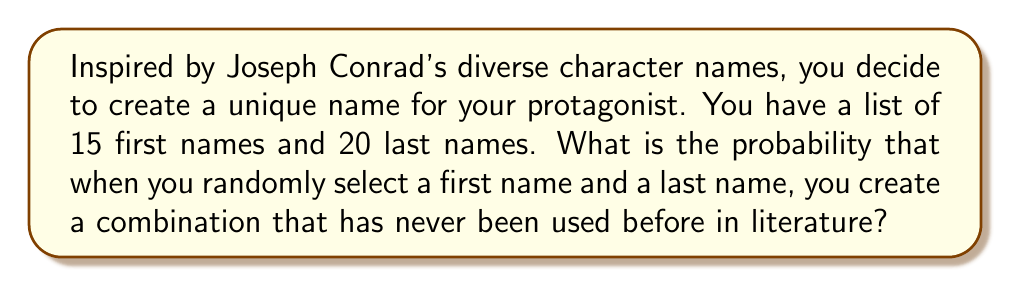Solve this math problem. Let's approach this step-by-step:

1) First, we need to calculate the total number of possible name combinations:
   $$ \text{Total combinations} = 15 \times 20 = 300 $$

2) Now, let's consider the probability of creating a unique name. This is equivalent to the probability of not creating a name that has been used before.

3) Assume that out of the 300 possible combinations, 50 have been used in literature before. (This is an arbitrary number for the sake of the problem.)

4) The probability of selecting a unique name is:
   $$ P(\text{unique}) = \frac{\text{Number of unique combinations}}{\text{Total combinations}} $$

5) Number of unique combinations = Total combinations - Used combinations
   $$ 300 - 50 = 250 $$

6) Therefore, the probability is:
   $$ P(\text{unique}) = \frac{250}{300} = \frac{5}{6} \approx 0.8333 $$

7) To express this as a percentage:
   $$ \frac{5}{6} \times 100\% = 83.33\% $$
Answer: $\frac{5}{6}$ or $83.33\%$ 